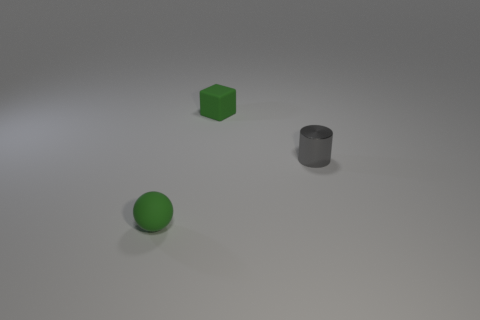Add 3 tiny shiny cylinders. How many objects exist? 6 Subtract all balls. How many objects are left? 2 Subtract all brown shiny cylinders. Subtract all tiny metallic objects. How many objects are left? 2 Add 1 tiny green matte things. How many tiny green matte things are left? 3 Add 1 green cubes. How many green cubes exist? 2 Subtract 0 green cylinders. How many objects are left? 3 Subtract 1 cylinders. How many cylinders are left? 0 Subtract all gray balls. Subtract all cyan cylinders. How many balls are left? 1 